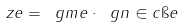Convert formula to latex. <formula><loc_0><loc_0><loc_500><loc_500>\ z e = \ g m e \cdot \ g n \in c \i e</formula> 